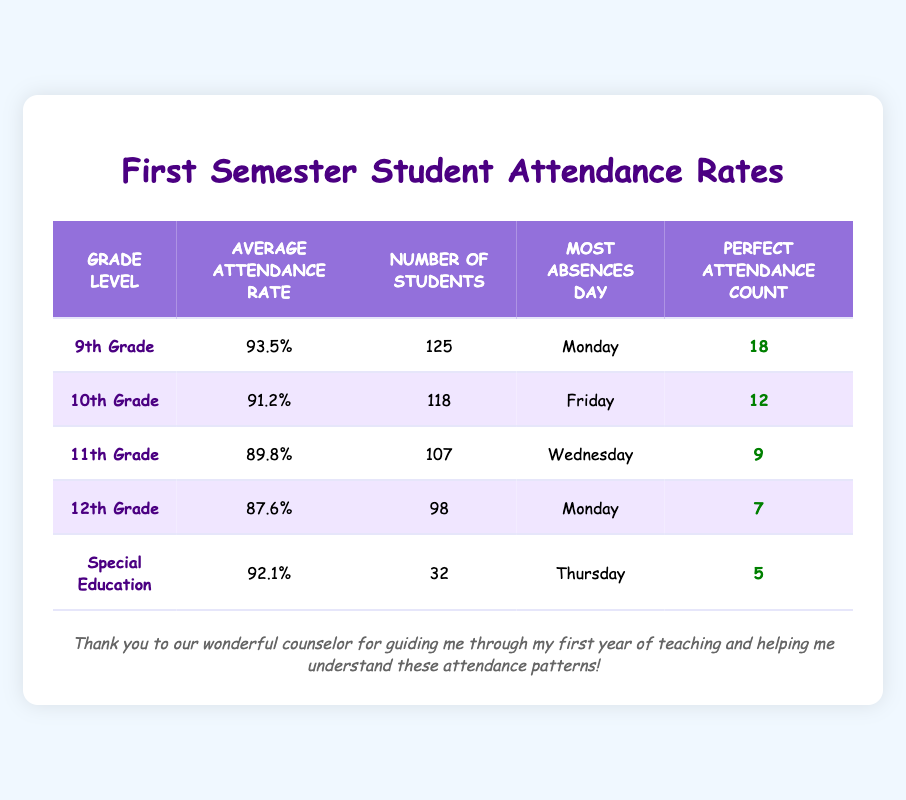What is the average attendance rate for 11th Grade? From the table, the average attendance rate for 11th Grade is listed directly as 89.8%.
Answer: 89.8% Which grade level has the highest number of students? By looking at the Number of Students column, 9th Grade has 125 students, which is higher than any other grade level listed.
Answer: 9th Grade Is the average attendance rate for the 12th Grade higher than that of the 10th Grade? The average attendance rate for 12th Grade is 87.6% and for 10th Grade, it is 91.2%. Since 87.6% is less than 91.2%, the answer is no.
Answer: No How many students in total have perfect attendance across all grade levels? By adding the Perfect Attendance Count from each grade level: 18 (9th) + 12 (10th) + 9 (11th) + 7 (12th) + 5 (Special Education) = 51 students with perfect attendance.
Answer: 51 Which grade level had the most absences on Mondays? From the Most Absences Day column, both 9th and 12th Grades have Mondays listed as the most absences day. Thus, both are valid answers. Therefore it can be concluded that 9th Grade has the higher attendance rate on average but both grades had absences on the same day.
Answer: 9th and 12th Grade 